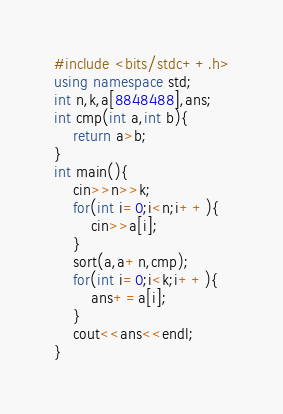<code> <loc_0><loc_0><loc_500><loc_500><_C++_>#include <bits/stdc++.h>
using namespace std;
int n,k,a[8848488],ans;
int cmp(int a,int b){
	return a>b;
}
int main(){
	cin>>n>>k;
	for(int i=0;i<n;i++){
		cin>>a[i];
	}
	sort(a,a+n,cmp);
	for(int i=0;i<k;i++){
		ans+=a[i];
	}
	cout<<ans<<endl;
}</code> 